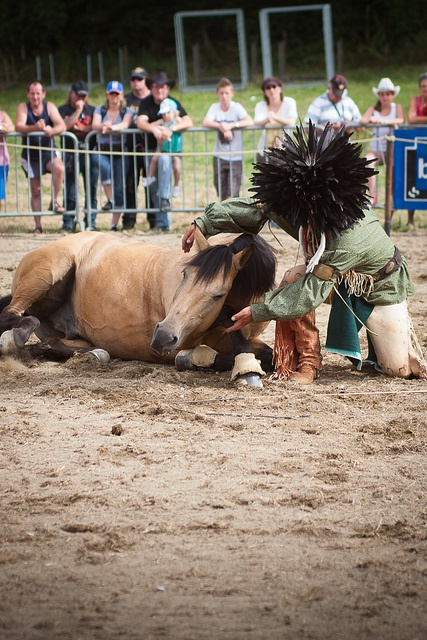Describe the objects in this image and their specific colors. I can see horse in black, gray, tan, and maroon tones, people in black, gray, darkgray, and lightgray tones, people in black, gray, lightgray, and lightpink tones, people in black, gray, lightpink, and brown tones, and people in black, darkgray, gray, and blue tones in this image. 